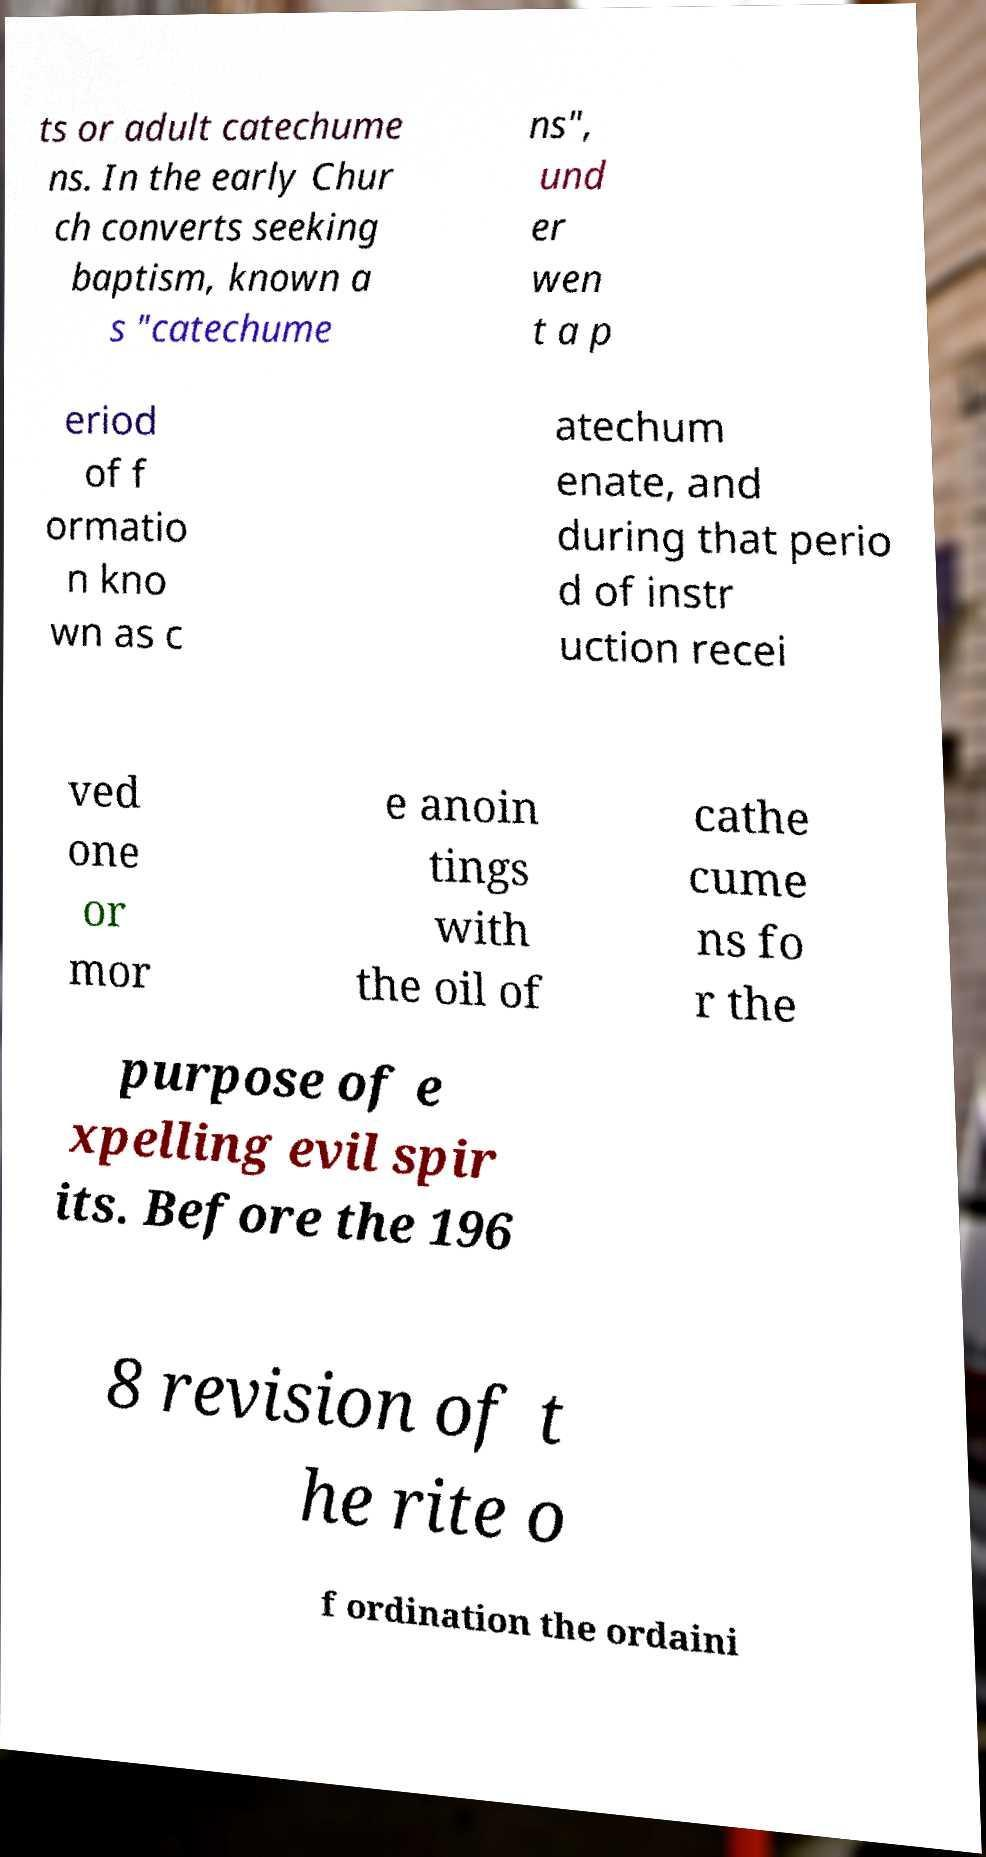Can you read and provide the text displayed in the image?This photo seems to have some interesting text. Can you extract and type it out for me? ts or adult catechume ns. In the early Chur ch converts seeking baptism, known a s "catechume ns", und er wen t a p eriod of f ormatio n kno wn as c atechum enate, and during that perio d of instr uction recei ved one or mor e anoin tings with the oil of cathe cume ns fo r the purpose of e xpelling evil spir its. Before the 196 8 revision of t he rite o f ordination the ordaini 